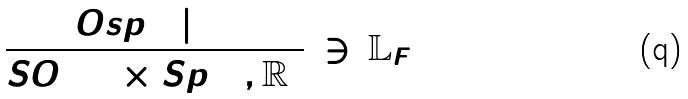<formula> <loc_0><loc_0><loc_500><loc_500>\frac { O s p ( 6 | \, 4 ) } { S O ( 6 ) \times S p ( 4 , \mathbb { R } ) } \, \ni \, \mathbb { L } _ { F }</formula> 